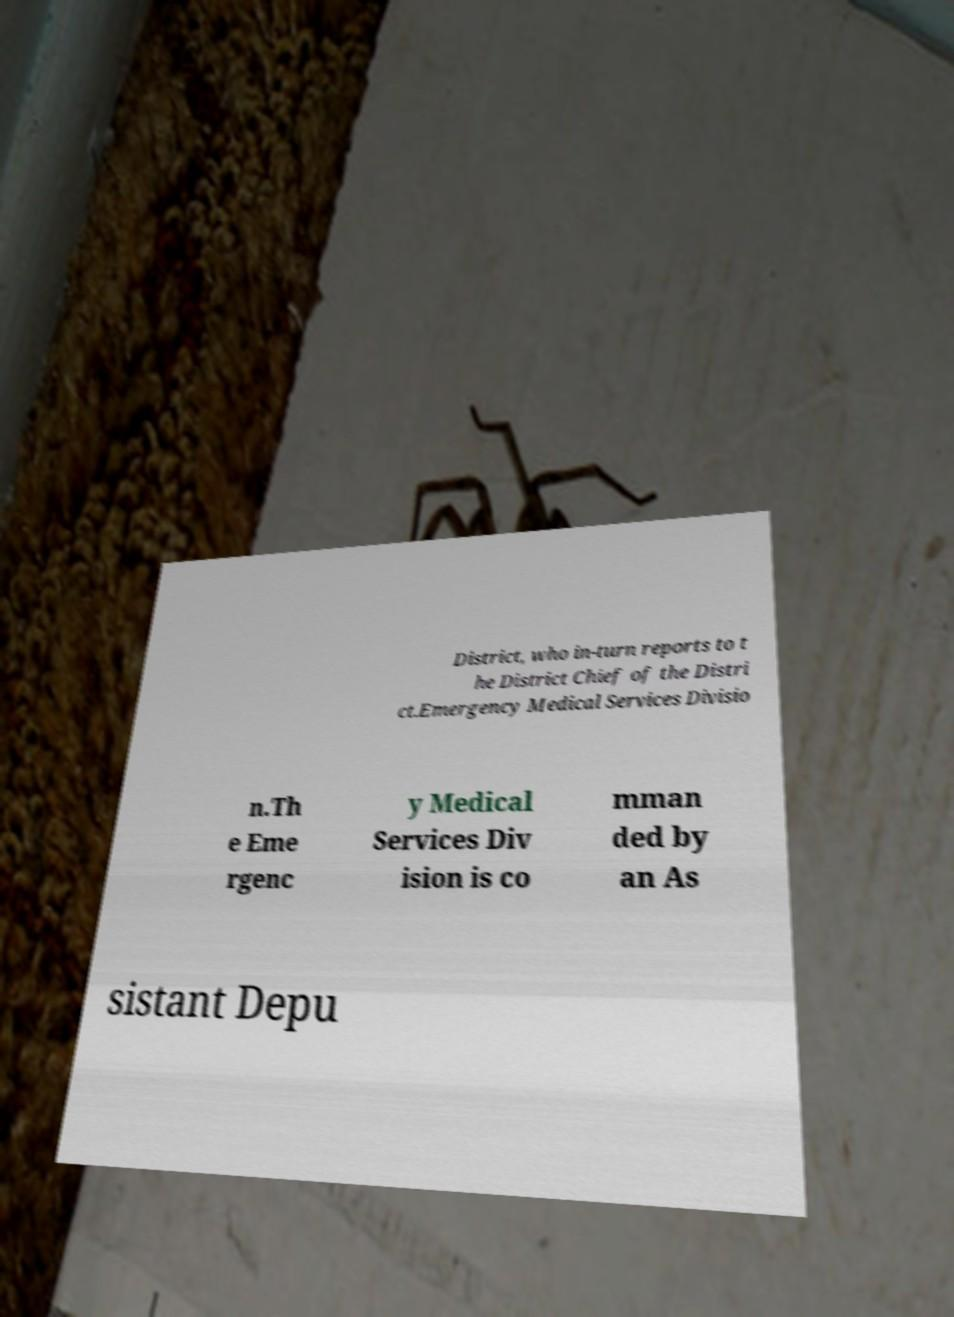I need the written content from this picture converted into text. Can you do that? District, who in-turn reports to t he District Chief of the Distri ct.Emergency Medical Services Divisio n.Th e Eme rgenc y Medical Services Div ision is co mman ded by an As sistant Depu 